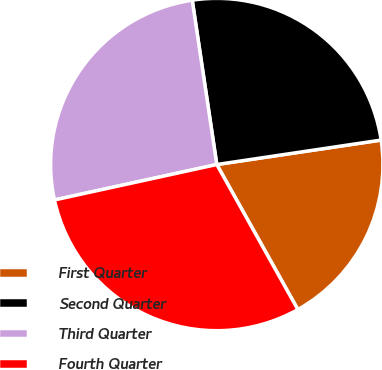<chart> <loc_0><loc_0><loc_500><loc_500><pie_chart><fcel>First Quarter<fcel>Second Quarter<fcel>Third Quarter<fcel>Fourth Quarter<nl><fcel>19.24%<fcel>25.01%<fcel>26.06%<fcel>29.69%<nl></chart> 